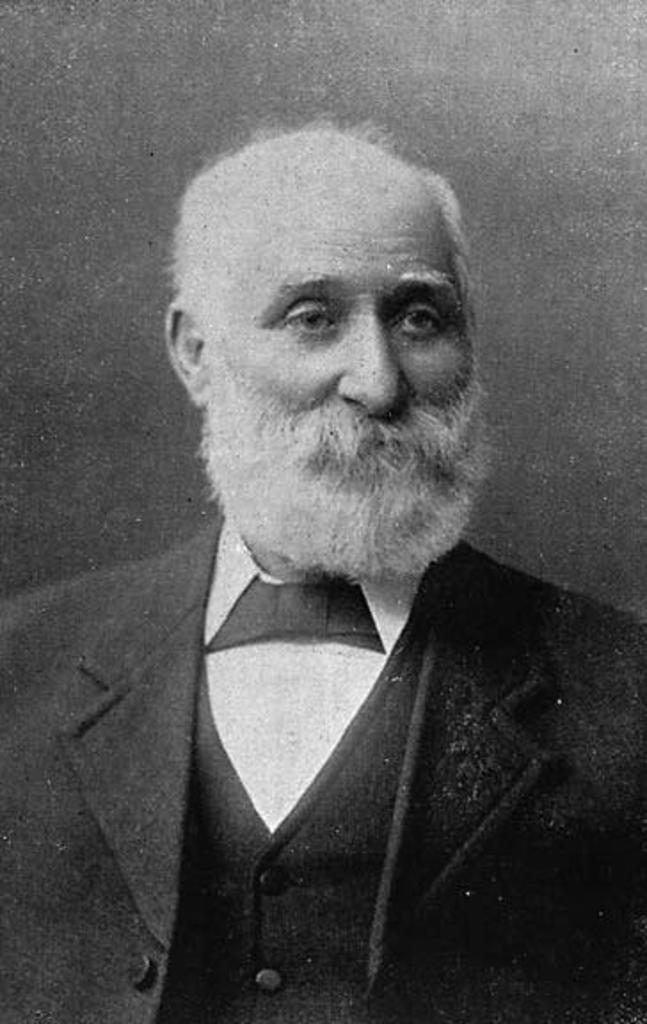What is the color scheme of the image? The image is black and white. Who is present in the image? There is a man in the image. What is the man wearing in the image? The man is wearing a suit and a shirt. What number is the man holding in the image? There is no number visible in the image. What rule is the man following in the image? There is no rule mentioned or depicted in the image. 